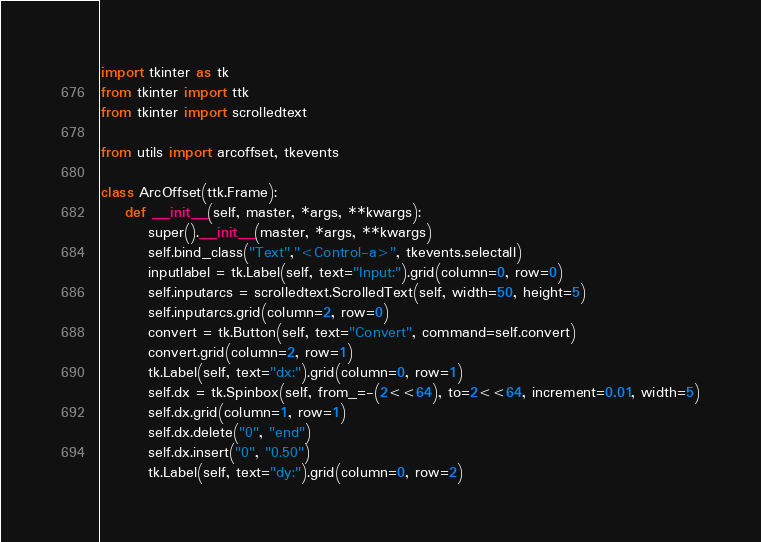<code> <loc_0><loc_0><loc_500><loc_500><_Python_>import tkinter as tk
from tkinter import ttk
from tkinter import scrolledtext

from utils import arcoffset, tkevents

class ArcOffset(ttk.Frame):
    def __init__(self, master, *args, **kwargs):
        super().__init__(master, *args, **kwargs)
        self.bind_class("Text","<Control-a>", tkevents.selectall)
        inputlabel = tk.Label(self, text="Input:").grid(column=0, row=0)
        self.inputarcs = scrolledtext.ScrolledText(self, width=50, height=5)
        self.inputarcs.grid(column=2, row=0)
        convert = tk.Button(self, text="Convert", command=self.convert)
        convert.grid(column=2, row=1)
        tk.Label(self, text="dx:").grid(column=0, row=1)
        self.dx = tk.Spinbox(self, from_=-(2<<64), to=2<<64, increment=0.01, width=5)
        self.dx.grid(column=1, row=1)
        self.dx.delete("0", "end")
        self.dx.insert("0", "0.50")
        tk.Label(self, text="dy:").grid(column=0, row=2)</code> 